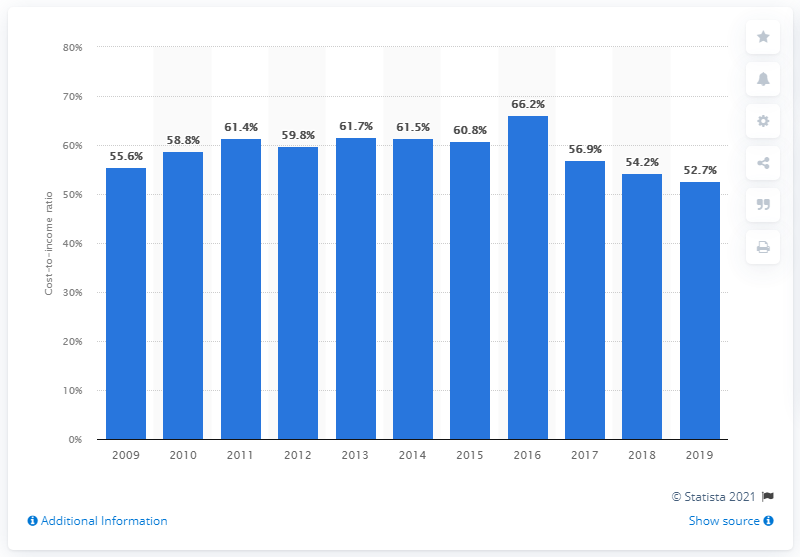Outline some significant characteristics in this image. From 2009 to 2016, UniCredit's cost-income ratio was 66.2%. In 2019, UniCredit's cost-income ratio was 52.7%, which indicates that the bank's expenses were 52.7% of its income. 